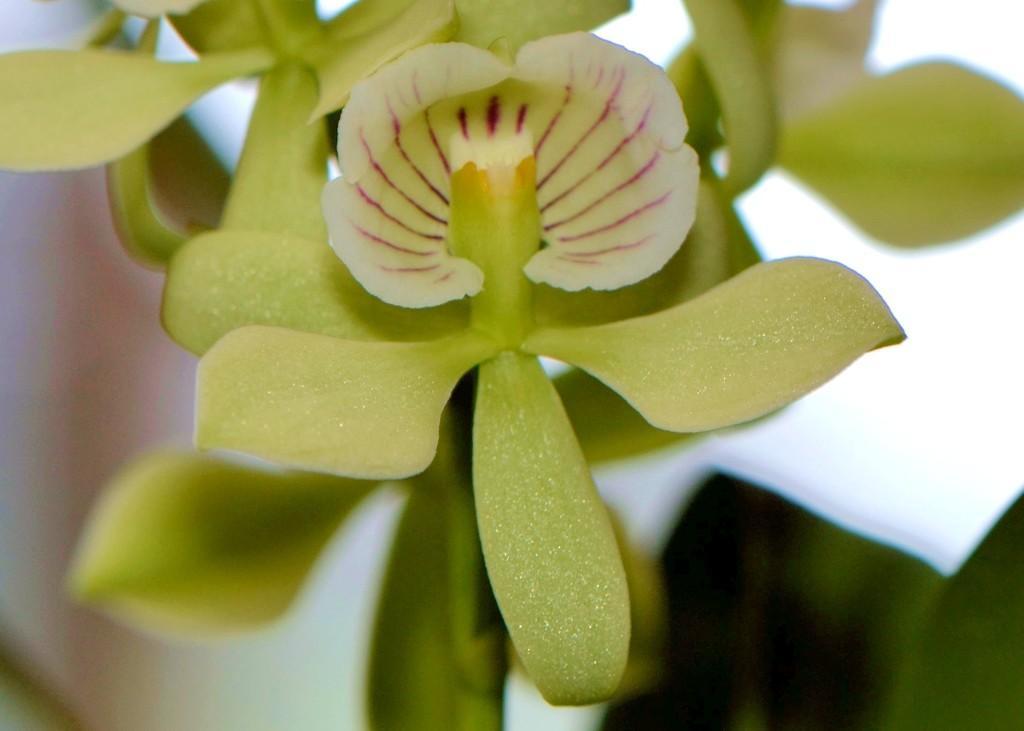How would you summarize this image in a sentence or two? In this image we can see a plant with a flower on it and the background is white. 